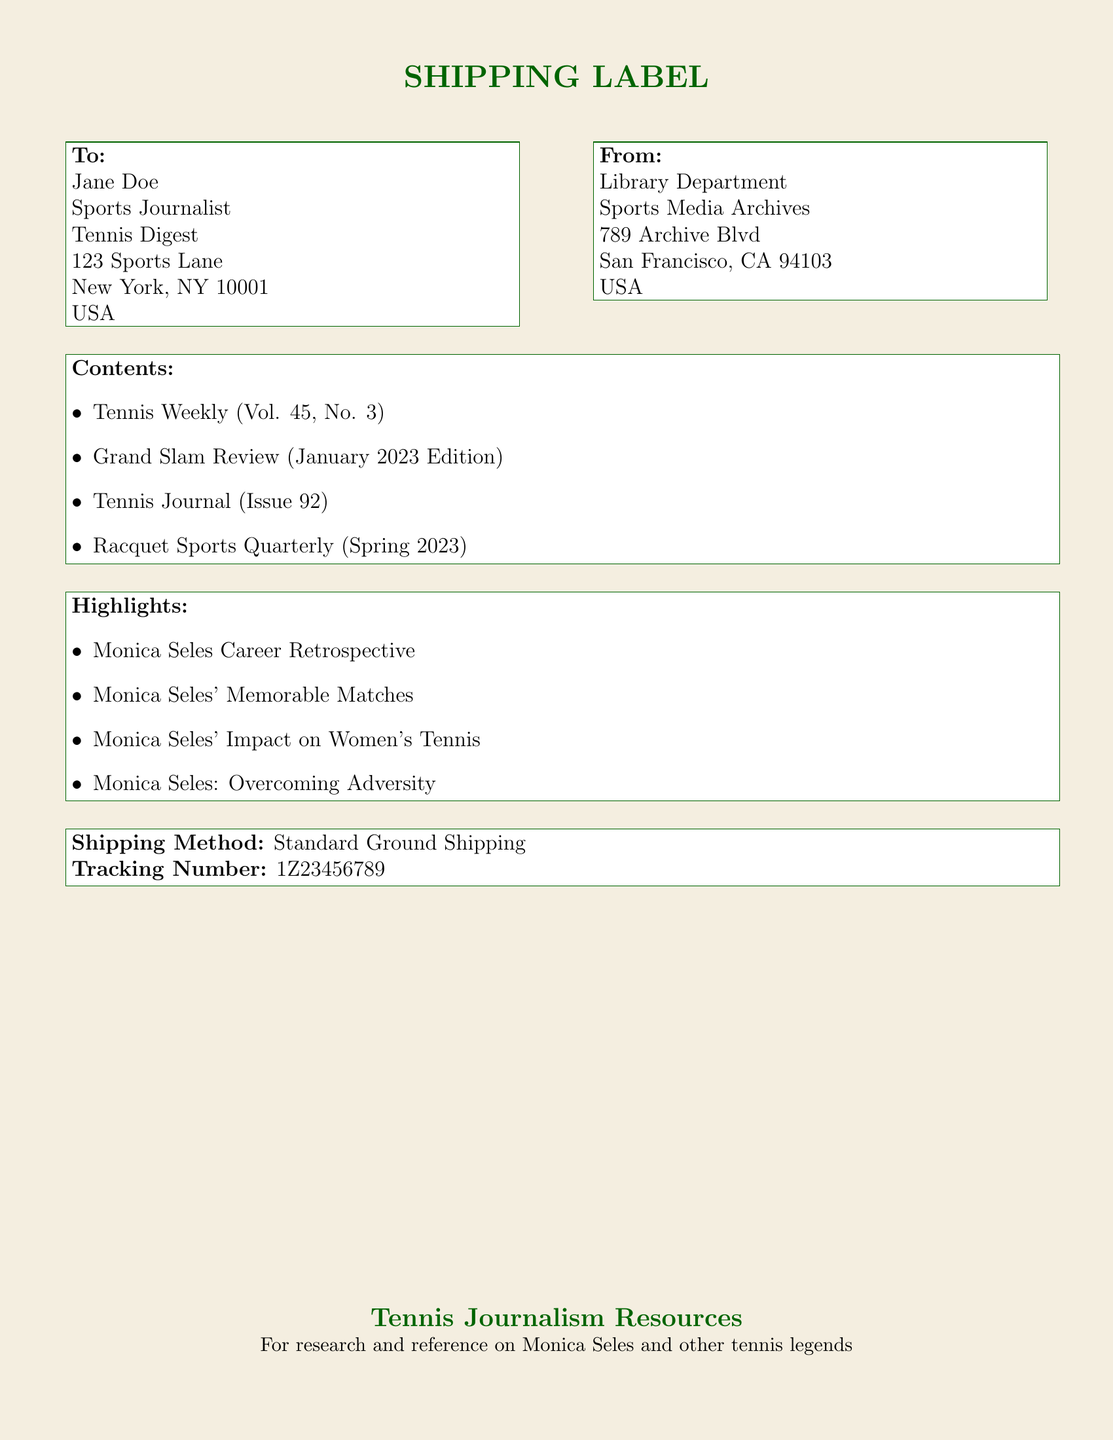What is the recipient's name? The recipient's name is listed in the "To" section of the document.
Answer: Jane Doe What is the shipping method? The shipping method is mentioned toward the end of the document.
Answer: Standard Ground Shipping What is the tracking number? The tracking number is specified in the shipping method section of the document.
Answer: 1Z23456789 Which magazine is included in the shipment? The magazines and journals included are listed in the "Contents" section of the document.
Answer: Tennis Weekly (Vol. 45, No. 3) What is one highlight related to Monica Seles? Highlights are provided under the "Highlights" section of the document.
Answer: Monica Seles Career Retrospective Where is the sender's address located? The sender's address is found in the "From" section of the document.
Answer: 789 Archive Blvd, San Francisco, CA 94103, USA How many items are listed in the "Contents" section? The number of items can be counted from the list provided in the document.
Answer: 4 What type of document is this? The overall nature of the document can be described by its title and formatting.
Answer: Shipping label 